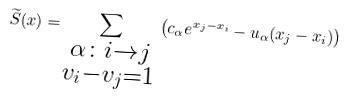<formula> <loc_0><loc_0><loc_500><loc_500>\widetilde { S } ( x ) = \sum _ { \substack { \alpha \colon i \to j \\ v _ { i } - v _ { j } = 1 } } \left ( c _ { \alpha } e ^ { x _ { j } - x _ { i } } - u _ { \alpha } ( x _ { j } - x _ { i } ) \right )</formula> 